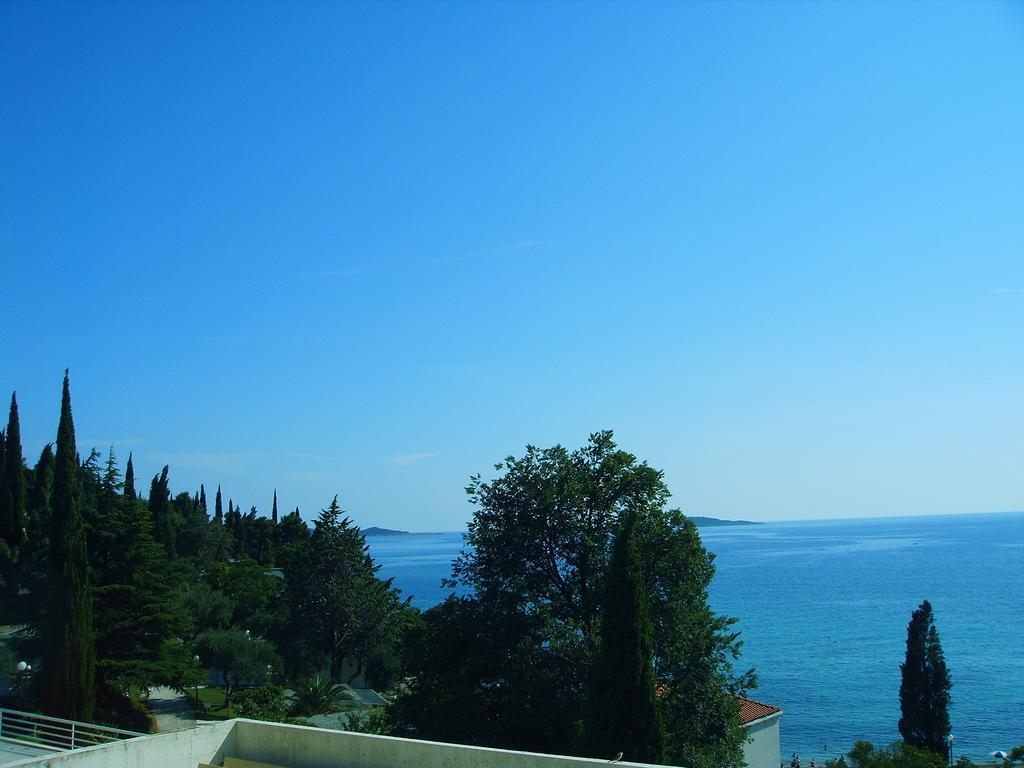What natural element can be seen in the image? Water is visible in the image. What type of vegetation is present in the image? There are trees and plants in the image. What man-made structure can be seen in the image? There is a road in the image. What type of buildings are visible in the image? There are buildings in the image. What geographical feature is present in the image? There is a hill in the image. What part of the natural environment is visible in the image? The sky is visible in the image. What atmospheric phenomenon can be seen in the sky? There are clouds visible in the image. What type of cup is being used by the achiever in the image? There is no achiever or cup present in the image. How does the balance of the hill affect the surrounding landscape in the image? The image does not show any indication of the balance of the hill affecting the surrounding landscape. 